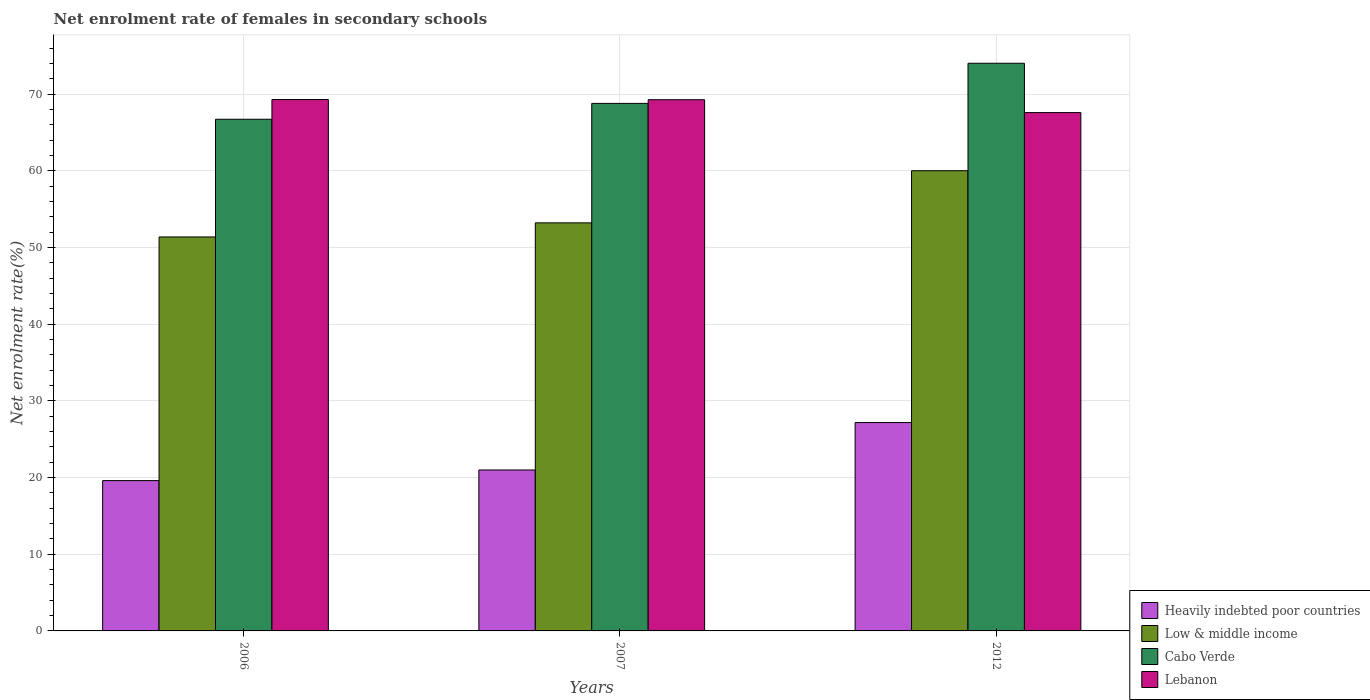How many groups of bars are there?
Provide a short and direct response. 3. Are the number of bars per tick equal to the number of legend labels?
Provide a succinct answer. Yes. Are the number of bars on each tick of the X-axis equal?
Provide a succinct answer. Yes. What is the net enrolment rate of females in secondary schools in Heavily indebted poor countries in 2006?
Keep it short and to the point. 19.61. Across all years, what is the maximum net enrolment rate of females in secondary schools in Heavily indebted poor countries?
Offer a very short reply. 27.18. Across all years, what is the minimum net enrolment rate of females in secondary schools in Lebanon?
Ensure brevity in your answer.  67.6. In which year was the net enrolment rate of females in secondary schools in Lebanon maximum?
Keep it short and to the point. 2006. What is the total net enrolment rate of females in secondary schools in Low & middle income in the graph?
Your response must be concise. 164.63. What is the difference between the net enrolment rate of females in secondary schools in Heavily indebted poor countries in 2007 and that in 2012?
Your answer should be very brief. -6.19. What is the difference between the net enrolment rate of females in secondary schools in Cabo Verde in 2006 and the net enrolment rate of females in secondary schools in Heavily indebted poor countries in 2012?
Your response must be concise. 39.56. What is the average net enrolment rate of females in secondary schools in Heavily indebted poor countries per year?
Provide a short and direct response. 22.59. In the year 2007, what is the difference between the net enrolment rate of females in secondary schools in Lebanon and net enrolment rate of females in secondary schools in Cabo Verde?
Ensure brevity in your answer.  0.48. In how many years, is the net enrolment rate of females in secondary schools in Lebanon greater than 34 %?
Offer a very short reply. 3. What is the ratio of the net enrolment rate of females in secondary schools in Heavily indebted poor countries in 2007 to that in 2012?
Your response must be concise. 0.77. Is the net enrolment rate of females in secondary schools in Cabo Verde in 2007 less than that in 2012?
Offer a terse response. Yes. Is the difference between the net enrolment rate of females in secondary schools in Lebanon in 2007 and 2012 greater than the difference between the net enrolment rate of females in secondary schools in Cabo Verde in 2007 and 2012?
Make the answer very short. Yes. What is the difference between the highest and the second highest net enrolment rate of females in secondary schools in Heavily indebted poor countries?
Your response must be concise. 6.19. What is the difference between the highest and the lowest net enrolment rate of females in secondary schools in Heavily indebted poor countries?
Give a very brief answer. 7.57. Is it the case that in every year, the sum of the net enrolment rate of females in secondary schools in Low & middle income and net enrolment rate of females in secondary schools in Heavily indebted poor countries is greater than the sum of net enrolment rate of females in secondary schools in Lebanon and net enrolment rate of females in secondary schools in Cabo Verde?
Give a very brief answer. No. What does the 1st bar from the left in 2007 represents?
Provide a succinct answer. Heavily indebted poor countries. Is it the case that in every year, the sum of the net enrolment rate of females in secondary schools in Low & middle income and net enrolment rate of females in secondary schools in Cabo Verde is greater than the net enrolment rate of females in secondary schools in Heavily indebted poor countries?
Offer a very short reply. Yes. Are all the bars in the graph horizontal?
Provide a short and direct response. No. Does the graph contain any zero values?
Give a very brief answer. No. How many legend labels are there?
Keep it short and to the point. 4. How are the legend labels stacked?
Your response must be concise. Vertical. What is the title of the graph?
Give a very brief answer. Net enrolment rate of females in secondary schools. What is the label or title of the Y-axis?
Your response must be concise. Net enrolment rate(%). What is the Net enrolment rate(%) in Heavily indebted poor countries in 2006?
Keep it short and to the point. 19.61. What is the Net enrolment rate(%) of Low & middle income in 2006?
Your answer should be compact. 51.38. What is the Net enrolment rate(%) of Cabo Verde in 2006?
Your answer should be compact. 66.73. What is the Net enrolment rate(%) of Lebanon in 2006?
Keep it short and to the point. 69.31. What is the Net enrolment rate(%) in Heavily indebted poor countries in 2007?
Keep it short and to the point. 20.99. What is the Net enrolment rate(%) of Low & middle income in 2007?
Offer a terse response. 53.22. What is the Net enrolment rate(%) in Cabo Verde in 2007?
Ensure brevity in your answer.  68.8. What is the Net enrolment rate(%) of Lebanon in 2007?
Offer a very short reply. 69.28. What is the Net enrolment rate(%) in Heavily indebted poor countries in 2012?
Offer a very short reply. 27.18. What is the Net enrolment rate(%) in Low & middle income in 2012?
Your answer should be compact. 60.02. What is the Net enrolment rate(%) of Cabo Verde in 2012?
Your answer should be very brief. 74.04. What is the Net enrolment rate(%) in Lebanon in 2012?
Your answer should be compact. 67.6. Across all years, what is the maximum Net enrolment rate(%) of Heavily indebted poor countries?
Your response must be concise. 27.18. Across all years, what is the maximum Net enrolment rate(%) of Low & middle income?
Give a very brief answer. 60.02. Across all years, what is the maximum Net enrolment rate(%) of Cabo Verde?
Offer a very short reply. 74.04. Across all years, what is the maximum Net enrolment rate(%) of Lebanon?
Your answer should be compact. 69.31. Across all years, what is the minimum Net enrolment rate(%) of Heavily indebted poor countries?
Your answer should be compact. 19.61. Across all years, what is the minimum Net enrolment rate(%) in Low & middle income?
Offer a terse response. 51.38. Across all years, what is the minimum Net enrolment rate(%) of Cabo Verde?
Provide a succinct answer. 66.73. Across all years, what is the minimum Net enrolment rate(%) in Lebanon?
Offer a very short reply. 67.6. What is the total Net enrolment rate(%) of Heavily indebted poor countries in the graph?
Keep it short and to the point. 67.77. What is the total Net enrolment rate(%) in Low & middle income in the graph?
Give a very brief answer. 164.63. What is the total Net enrolment rate(%) of Cabo Verde in the graph?
Your answer should be compact. 209.58. What is the total Net enrolment rate(%) in Lebanon in the graph?
Give a very brief answer. 206.19. What is the difference between the Net enrolment rate(%) of Heavily indebted poor countries in 2006 and that in 2007?
Your answer should be very brief. -1.39. What is the difference between the Net enrolment rate(%) in Low & middle income in 2006 and that in 2007?
Offer a terse response. -1.84. What is the difference between the Net enrolment rate(%) of Cabo Verde in 2006 and that in 2007?
Offer a very short reply. -2.07. What is the difference between the Net enrolment rate(%) in Lebanon in 2006 and that in 2007?
Give a very brief answer. 0.02. What is the difference between the Net enrolment rate(%) of Heavily indebted poor countries in 2006 and that in 2012?
Make the answer very short. -7.57. What is the difference between the Net enrolment rate(%) of Low & middle income in 2006 and that in 2012?
Provide a succinct answer. -8.64. What is the difference between the Net enrolment rate(%) in Cabo Verde in 2006 and that in 2012?
Make the answer very short. -7.3. What is the difference between the Net enrolment rate(%) in Lebanon in 2006 and that in 2012?
Give a very brief answer. 1.7. What is the difference between the Net enrolment rate(%) of Heavily indebted poor countries in 2007 and that in 2012?
Your answer should be compact. -6.19. What is the difference between the Net enrolment rate(%) of Low & middle income in 2007 and that in 2012?
Make the answer very short. -6.8. What is the difference between the Net enrolment rate(%) in Cabo Verde in 2007 and that in 2012?
Offer a terse response. -5.23. What is the difference between the Net enrolment rate(%) of Lebanon in 2007 and that in 2012?
Make the answer very short. 1.68. What is the difference between the Net enrolment rate(%) of Heavily indebted poor countries in 2006 and the Net enrolment rate(%) of Low & middle income in 2007?
Your answer should be very brief. -33.62. What is the difference between the Net enrolment rate(%) in Heavily indebted poor countries in 2006 and the Net enrolment rate(%) in Cabo Verde in 2007?
Offer a terse response. -49.2. What is the difference between the Net enrolment rate(%) in Heavily indebted poor countries in 2006 and the Net enrolment rate(%) in Lebanon in 2007?
Provide a succinct answer. -49.68. What is the difference between the Net enrolment rate(%) in Low & middle income in 2006 and the Net enrolment rate(%) in Cabo Verde in 2007?
Make the answer very short. -17.42. What is the difference between the Net enrolment rate(%) of Low & middle income in 2006 and the Net enrolment rate(%) of Lebanon in 2007?
Make the answer very short. -17.9. What is the difference between the Net enrolment rate(%) in Cabo Verde in 2006 and the Net enrolment rate(%) in Lebanon in 2007?
Offer a very short reply. -2.55. What is the difference between the Net enrolment rate(%) in Heavily indebted poor countries in 2006 and the Net enrolment rate(%) in Low & middle income in 2012?
Provide a short and direct response. -40.42. What is the difference between the Net enrolment rate(%) of Heavily indebted poor countries in 2006 and the Net enrolment rate(%) of Cabo Verde in 2012?
Provide a succinct answer. -54.43. What is the difference between the Net enrolment rate(%) in Heavily indebted poor countries in 2006 and the Net enrolment rate(%) in Lebanon in 2012?
Your response must be concise. -48. What is the difference between the Net enrolment rate(%) in Low & middle income in 2006 and the Net enrolment rate(%) in Cabo Verde in 2012?
Your answer should be very brief. -22.65. What is the difference between the Net enrolment rate(%) of Low & middle income in 2006 and the Net enrolment rate(%) of Lebanon in 2012?
Your response must be concise. -16.22. What is the difference between the Net enrolment rate(%) of Cabo Verde in 2006 and the Net enrolment rate(%) of Lebanon in 2012?
Offer a terse response. -0.87. What is the difference between the Net enrolment rate(%) of Heavily indebted poor countries in 2007 and the Net enrolment rate(%) of Low & middle income in 2012?
Provide a short and direct response. -39.03. What is the difference between the Net enrolment rate(%) of Heavily indebted poor countries in 2007 and the Net enrolment rate(%) of Cabo Verde in 2012?
Give a very brief answer. -53.05. What is the difference between the Net enrolment rate(%) in Heavily indebted poor countries in 2007 and the Net enrolment rate(%) in Lebanon in 2012?
Offer a terse response. -46.61. What is the difference between the Net enrolment rate(%) in Low & middle income in 2007 and the Net enrolment rate(%) in Cabo Verde in 2012?
Your answer should be compact. -20.81. What is the difference between the Net enrolment rate(%) in Low & middle income in 2007 and the Net enrolment rate(%) in Lebanon in 2012?
Offer a very short reply. -14.38. What is the difference between the Net enrolment rate(%) of Cabo Verde in 2007 and the Net enrolment rate(%) of Lebanon in 2012?
Make the answer very short. 1.2. What is the average Net enrolment rate(%) in Heavily indebted poor countries per year?
Your answer should be very brief. 22.59. What is the average Net enrolment rate(%) of Low & middle income per year?
Provide a succinct answer. 54.88. What is the average Net enrolment rate(%) in Cabo Verde per year?
Keep it short and to the point. 69.86. What is the average Net enrolment rate(%) of Lebanon per year?
Ensure brevity in your answer.  68.73. In the year 2006, what is the difference between the Net enrolment rate(%) of Heavily indebted poor countries and Net enrolment rate(%) of Low & middle income?
Provide a short and direct response. -31.78. In the year 2006, what is the difference between the Net enrolment rate(%) in Heavily indebted poor countries and Net enrolment rate(%) in Cabo Verde?
Offer a terse response. -47.13. In the year 2006, what is the difference between the Net enrolment rate(%) of Heavily indebted poor countries and Net enrolment rate(%) of Lebanon?
Ensure brevity in your answer.  -49.7. In the year 2006, what is the difference between the Net enrolment rate(%) of Low & middle income and Net enrolment rate(%) of Cabo Verde?
Your response must be concise. -15.35. In the year 2006, what is the difference between the Net enrolment rate(%) of Low & middle income and Net enrolment rate(%) of Lebanon?
Offer a very short reply. -17.92. In the year 2006, what is the difference between the Net enrolment rate(%) in Cabo Verde and Net enrolment rate(%) in Lebanon?
Provide a succinct answer. -2.57. In the year 2007, what is the difference between the Net enrolment rate(%) of Heavily indebted poor countries and Net enrolment rate(%) of Low & middle income?
Provide a succinct answer. -32.23. In the year 2007, what is the difference between the Net enrolment rate(%) in Heavily indebted poor countries and Net enrolment rate(%) in Cabo Verde?
Ensure brevity in your answer.  -47.81. In the year 2007, what is the difference between the Net enrolment rate(%) of Heavily indebted poor countries and Net enrolment rate(%) of Lebanon?
Provide a succinct answer. -48.29. In the year 2007, what is the difference between the Net enrolment rate(%) in Low & middle income and Net enrolment rate(%) in Cabo Verde?
Offer a very short reply. -15.58. In the year 2007, what is the difference between the Net enrolment rate(%) of Low & middle income and Net enrolment rate(%) of Lebanon?
Your response must be concise. -16.06. In the year 2007, what is the difference between the Net enrolment rate(%) in Cabo Verde and Net enrolment rate(%) in Lebanon?
Make the answer very short. -0.48. In the year 2012, what is the difference between the Net enrolment rate(%) in Heavily indebted poor countries and Net enrolment rate(%) in Low & middle income?
Ensure brevity in your answer.  -32.85. In the year 2012, what is the difference between the Net enrolment rate(%) of Heavily indebted poor countries and Net enrolment rate(%) of Cabo Verde?
Give a very brief answer. -46.86. In the year 2012, what is the difference between the Net enrolment rate(%) of Heavily indebted poor countries and Net enrolment rate(%) of Lebanon?
Keep it short and to the point. -40.43. In the year 2012, what is the difference between the Net enrolment rate(%) of Low & middle income and Net enrolment rate(%) of Cabo Verde?
Keep it short and to the point. -14.01. In the year 2012, what is the difference between the Net enrolment rate(%) in Low & middle income and Net enrolment rate(%) in Lebanon?
Ensure brevity in your answer.  -7.58. In the year 2012, what is the difference between the Net enrolment rate(%) of Cabo Verde and Net enrolment rate(%) of Lebanon?
Your response must be concise. 6.43. What is the ratio of the Net enrolment rate(%) of Heavily indebted poor countries in 2006 to that in 2007?
Provide a succinct answer. 0.93. What is the ratio of the Net enrolment rate(%) of Low & middle income in 2006 to that in 2007?
Your answer should be compact. 0.97. What is the ratio of the Net enrolment rate(%) of Cabo Verde in 2006 to that in 2007?
Keep it short and to the point. 0.97. What is the ratio of the Net enrolment rate(%) of Lebanon in 2006 to that in 2007?
Ensure brevity in your answer.  1. What is the ratio of the Net enrolment rate(%) of Heavily indebted poor countries in 2006 to that in 2012?
Provide a succinct answer. 0.72. What is the ratio of the Net enrolment rate(%) of Low & middle income in 2006 to that in 2012?
Offer a very short reply. 0.86. What is the ratio of the Net enrolment rate(%) of Cabo Verde in 2006 to that in 2012?
Ensure brevity in your answer.  0.9. What is the ratio of the Net enrolment rate(%) of Lebanon in 2006 to that in 2012?
Your answer should be compact. 1.03. What is the ratio of the Net enrolment rate(%) in Heavily indebted poor countries in 2007 to that in 2012?
Provide a succinct answer. 0.77. What is the ratio of the Net enrolment rate(%) in Low & middle income in 2007 to that in 2012?
Provide a short and direct response. 0.89. What is the ratio of the Net enrolment rate(%) in Cabo Verde in 2007 to that in 2012?
Your response must be concise. 0.93. What is the ratio of the Net enrolment rate(%) in Lebanon in 2007 to that in 2012?
Provide a short and direct response. 1.02. What is the difference between the highest and the second highest Net enrolment rate(%) of Heavily indebted poor countries?
Give a very brief answer. 6.19. What is the difference between the highest and the second highest Net enrolment rate(%) in Low & middle income?
Provide a succinct answer. 6.8. What is the difference between the highest and the second highest Net enrolment rate(%) in Cabo Verde?
Your answer should be very brief. 5.23. What is the difference between the highest and the second highest Net enrolment rate(%) in Lebanon?
Give a very brief answer. 0.02. What is the difference between the highest and the lowest Net enrolment rate(%) of Heavily indebted poor countries?
Your response must be concise. 7.57. What is the difference between the highest and the lowest Net enrolment rate(%) of Low & middle income?
Ensure brevity in your answer.  8.64. What is the difference between the highest and the lowest Net enrolment rate(%) of Cabo Verde?
Give a very brief answer. 7.3. What is the difference between the highest and the lowest Net enrolment rate(%) in Lebanon?
Provide a short and direct response. 1.7. 